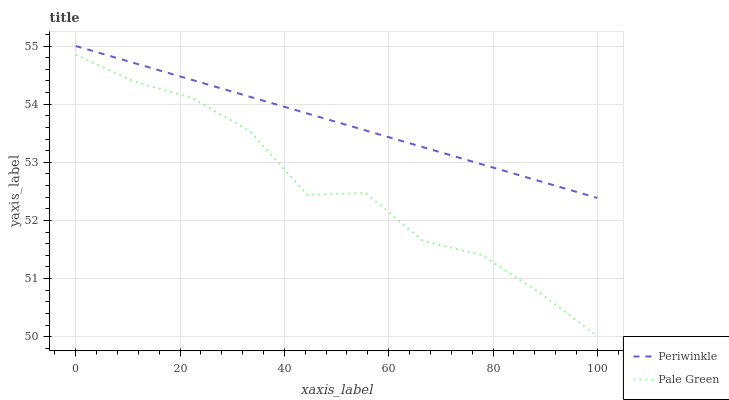Does Pale Green have the minimum area under the curve?
Answer yes or no. Yes. Does Periwinkle have the maximum area under the curve?
Answer yes or no. Yes. Does Periwinkle have the minimum area under the curve?
Answer yes or no. No. Is Periwinkle the smoothest?
Answer yes or no. Yes. Is Pale Green the roughest?
Answer yes or no. Yes. Is Periwinkle the roughest?
Answer yes or no. No. Does Pale Green have the lowest value?
Answer yes or no. Yes. Does Periwinkle have the lowest value?
Answer yes or no. No. Does Periwinkle have the highest value?
Answer yes or no. Yes. Is Pale Green less than Periwinkle?
Answer yes or no. Yes. Is Periwinkle greater than Pale Green?
Answer yes or no. Yes. Does Pale Green intersect Periwinkle?
Answer yes or no. No. 